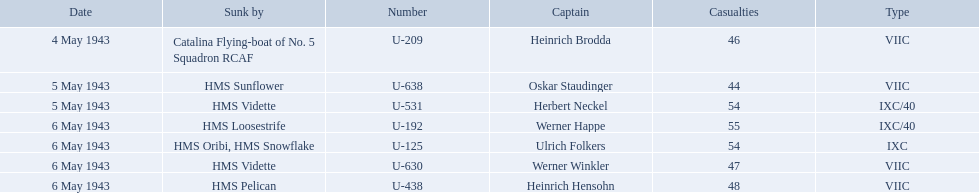What is the list of ships under sunk by? Catalina Flying-boat of No. 5 Squadron RCAF, HMS Sunflower, HMS Vidette, HMS Loosestrife, HMS Oribi, HMS Snowflake, HMS Vidette, HMS Pelican. Which captains did hms pelican sink? Heinrich Hensohn. Who were the captains in the ons 5 convoy? Heinrich Brodda, Oskar Staudinger, Herbert Neckel, Werner Happe, Ulrich Folkers, Werner Winkler, Heinrich Hensohn. Which ones lost their u-boat on may 5? Oskar Staudinger, Herbert Neckel. Of those, which one is not oskar staudinger? Herbert Neckel. 